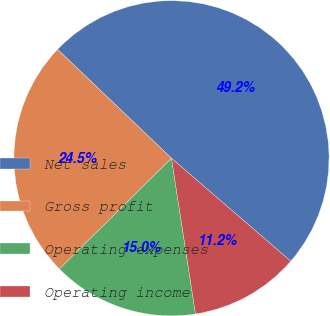Convert chart. <chart><loc_0><loc_0><loc_500><loc_500><pie_chart><fcel>Net sales<fcel>Gross profit<fcel>Operating expenses<fcel>Operating income<nl><fcel>49.19%<fcel>24.54%<fcel>15.03%<fcel>11.23%<nl></chart> 